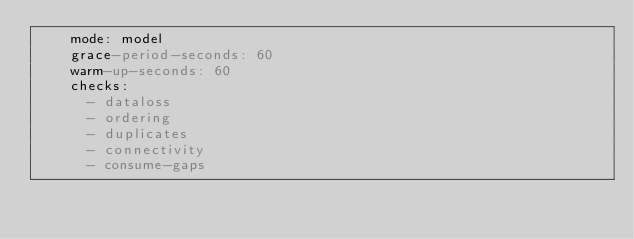Convert code to text. <code><loc_0><loc_0><loc_500><loc_500><_YAML_>    mode: model
    grace-period-seconds: 60
    warm-up-seconds: 60
    checks:
      - dataloss
      - ordering
      - duplicates
      - connectivity
      - consume-gaps</code> 